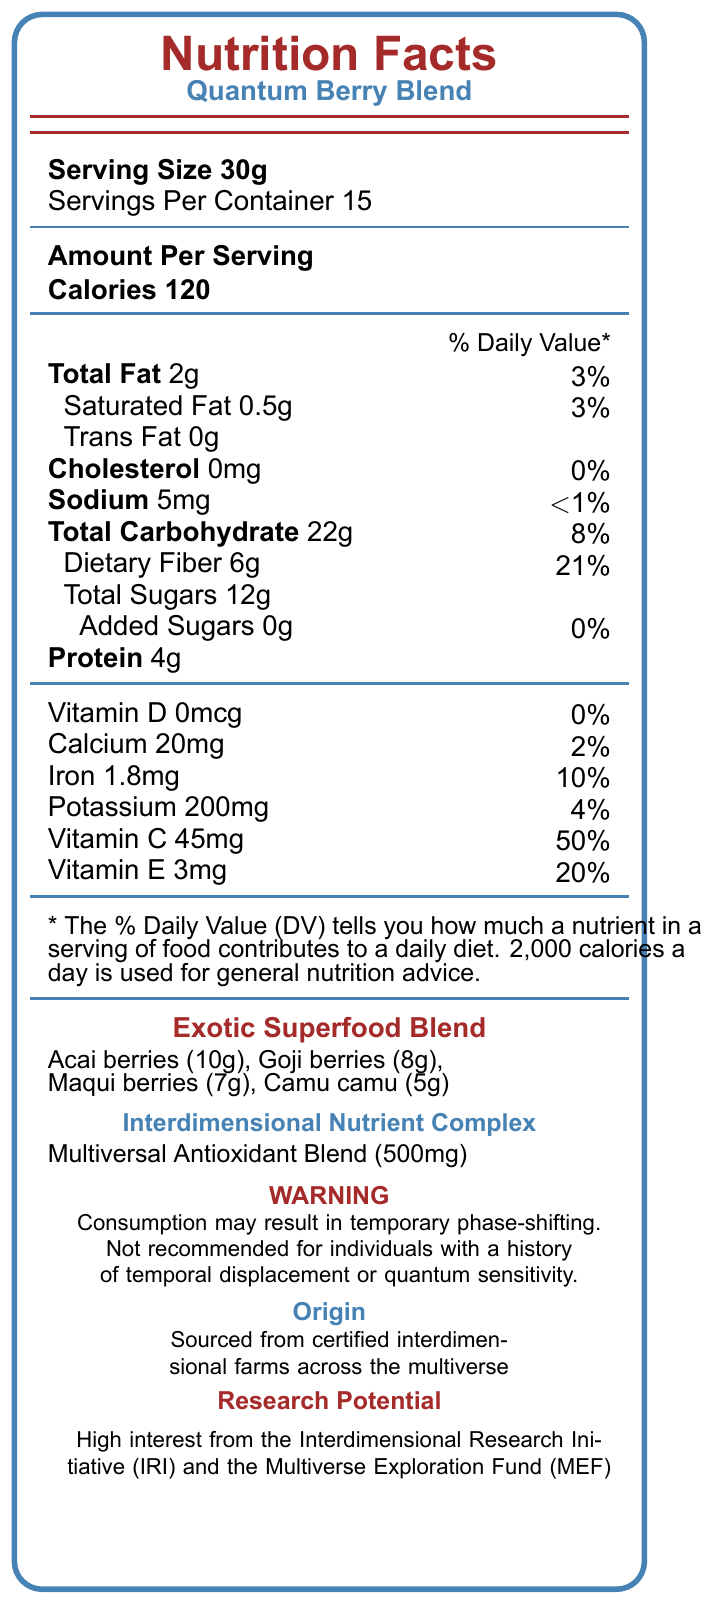what is the serving size? The serving size is clearly stated as "Serving Size 30g" near the top of the document.
Answer: 30g how many servings are there per container? It is stated as "Servings Per Container 15" near the top of the document.
Answer: 15 what is the total carbohydrate content in one serving? The document lists "Total Carbohydrate 22g" with a daily value percentage of 8%.
Answer: 22g how much dietary fiber does one serving contain? The document provides the amount of "Dietary Fiber 6g" with a daily value of 21%.
Answer: 6g what is the main interdimensional property of Goji berries in this blend? The document states that the interdimensional property of Goji berries is "Quantum entanglement enhancement".
Answer: Quantum entanglement enhancement which of the following vitamins has the highest daily value percentage? A. Vitamin D B. Calcium C. Vitamin C D. Iron Vitamin C has the highest daily value percentage at 50%. Vitamin D is 0%, Calcium is 2%, and Iron is 10%.
Answer: C what is the total fat content in one serving? The document lists "Total Fat 2g" with a corresponding daily value of 3%.
Answer: 2g which superfood is associated with multiverse navigation support? A. Acai berries B. Goji berries C. Maqui berries D. Camu camu The document states that Maqui berries provide "Multiverse navigation support".
Answer: C how many mcg of Vitamin D are in one serving? The document lists "Vitamin D 0mcg" with a daily value of 0%.
Answer: 0mcg is there any trans fat in this product? The document lists "Trans Fat 0g".
Answer: No summarize the main idea of the document. The summary encapsulates the overall content and main sections of the document, from nutritional facts to exotic superfoods and related research notes.
Answer: The document provides nutritional information for "Quantum Berry Blend," a product containing exotic superfoods with interdimensional properties. It lists the nutritional content per 30g serving, including calorie content, macro and micro-nutrient values, as well as the interdimensional properties of its components. A warning about potential phase-shifting and the origin of the ingredients is also included. what is the primary purpose of the Multiversal Antioxidant Blend? The document mentions the components of the Multiversal Antioxidant Blend but does not provide enough specific details about its primary purpose.
Answer: Not enough information how many grams of protein are in one serving? The document lists "Protein 4g" under the nutritional information section.
Answer: 4g how much Vitamin C does one serving contain, and what is its daily value percentage? The document lists "Vitamin C 45mg" with a daily value percentage of 50%.
Answer: 45mg, 50% is this product recommended for individuals with a history of temporal displacement? The warning states, "Not recommended for individuals with a history of temporal displacement or quantum sensitivity."
Answer: No which organization shows high interest in funding this research? A. Quantum Research Society B. Parallel Universe Foundation C. Interdimensional Research Initiative D. Multiverse Exploration Society The document indicates that both the "Interdimensional Research Initiative (IRI)" and the "Multiverse Exploration Fund (MEF)" show high interest in this research.
Answer: C, D 